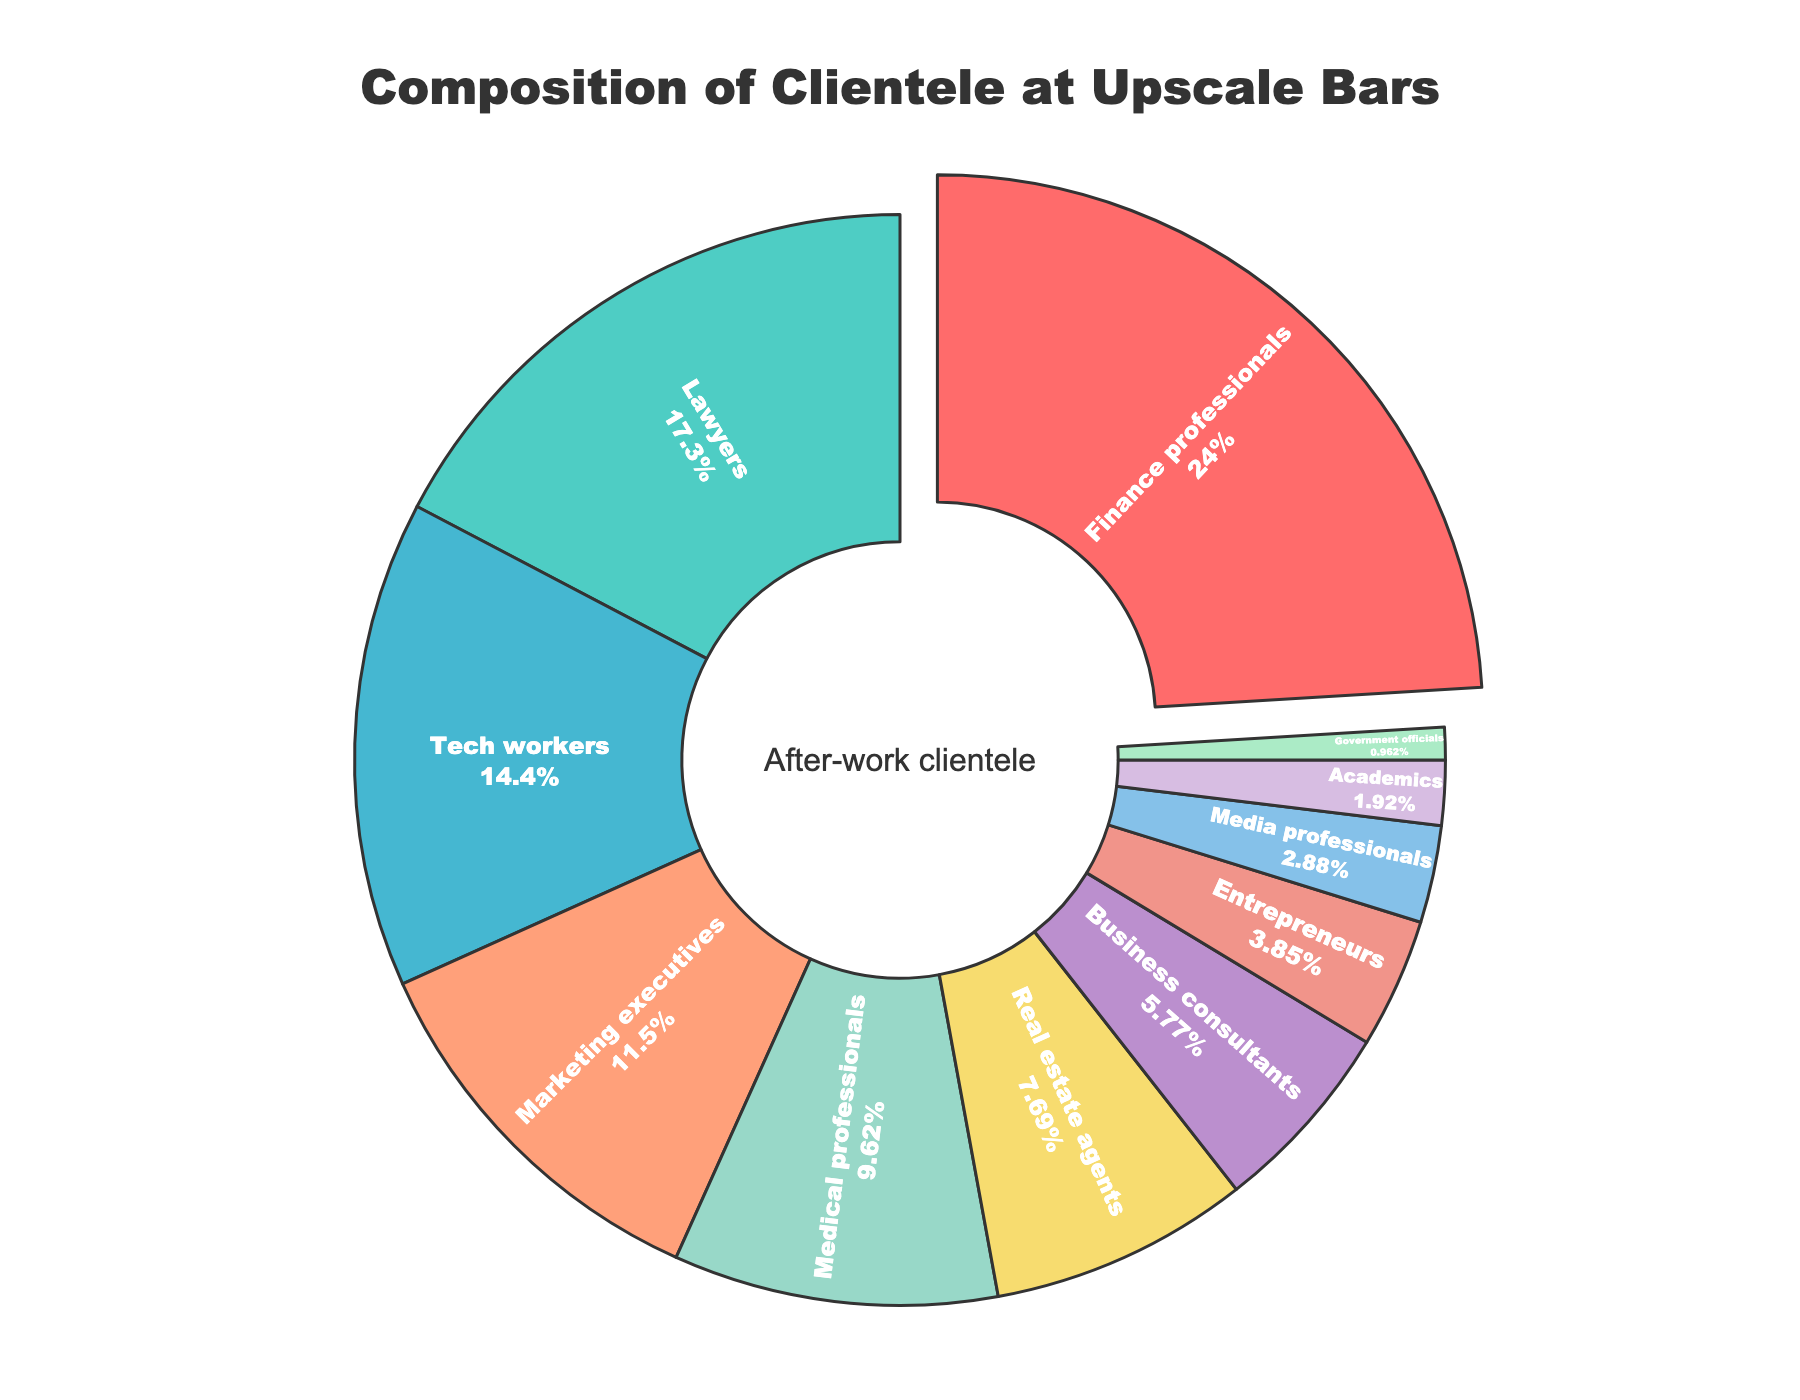What profession has the highest percentage of clientele at upscale bars? By looking at the pie chart, "Finance professionals" occupy the largest section, indicating they have the highest percentage of clientele.
Answer: Finance professionals What is the total percentage of clientele represented by Tech workers and Marketing executives combined? By adding the percentages of Tech workers (15%) and Marketing executives (12%), we get a total of 27%.
Answer: 27% Which profession has a lower percentage of clientele, Medical professionals or Real estate agents? By comparing the two sections of the pie chart, we see Medical professionals have 10%, whereas Real estate agents have 8%, making the latter lower.
Answer: Real estate agents What is the combined percentage of clientele for professions that have less than 5% each? Adding the percentages of Entrepreneurs (4%), Media professionals (3%), Academics (2%), and Government officials (1%) yields a total of 10%.
Answer: 10% How much greater is the percentage of Lawyers compared to Academics? Subtract the percentage of Academics (2%) from the percentage of Lawyers (18%); 18% - 2% = 16%.
Answer: 16% What color represents the Finance professionals in the pie chart? By observing the visual attributes, Finance professionals are represented by the color red, which is the first section in the sorted order.
Answer: Red What is the difference in percentage between the profession with the smallest clientele and the profession with the largest clientele? Subtract the percentage of Government officials (1%), the smallest, from Finance professionals (25%), the largest; 25% - 1% = 24%.
Answer: 24% Which professions are represented by yellow and light purple colors in the pie chart? By referring to the color sequence in the pie chart, the color yellow represents Real estate agents (8%) and light purple represents Business consultants (6%).
Answer: Real estate agents, Business consultants What proportion of the total clientele do Business consultants and Entrepreneurs together represent? Summing up their percentages, Business consultants (6%) and Entrepreneurs (4%) give a combined total of 10%.
Answer: 10% Which professional group is represented by the smallest slice of the pie chart? Observing the smallest slice, Government officials, which constitute 1% of the clientele, are represented by it.
Answer: Government officials 